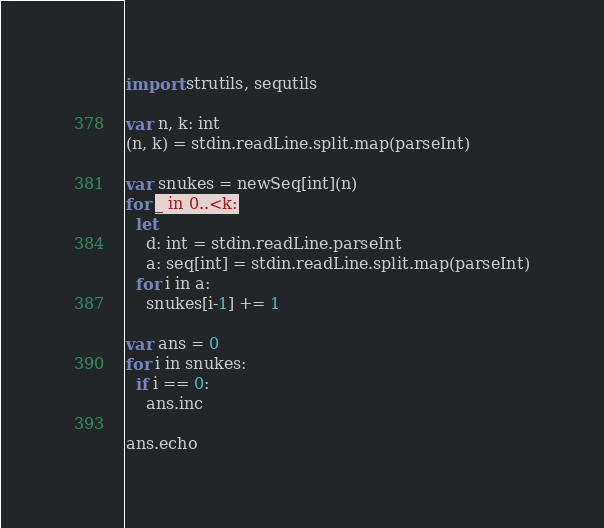Convert code to text. <code><loc_0><loc_0><loc_500><loc_500><_Nim_>import strutils, sequtils

var n, k: int
(n, k) = stdin.readLine.split.map(parseInt)

var snukes = newSeq[int](n)
for _ in 0..<k:
  let
    d: int = stdin.readLine.parseInt
    a: seq[int] = stdin.readLine.split.map(parseInt)
  for i in a:
    snukes[i-1] += 1

var ans = 0
for i in snukes:
  if i == 0:
    ans.inc

ans.echo
</code> 